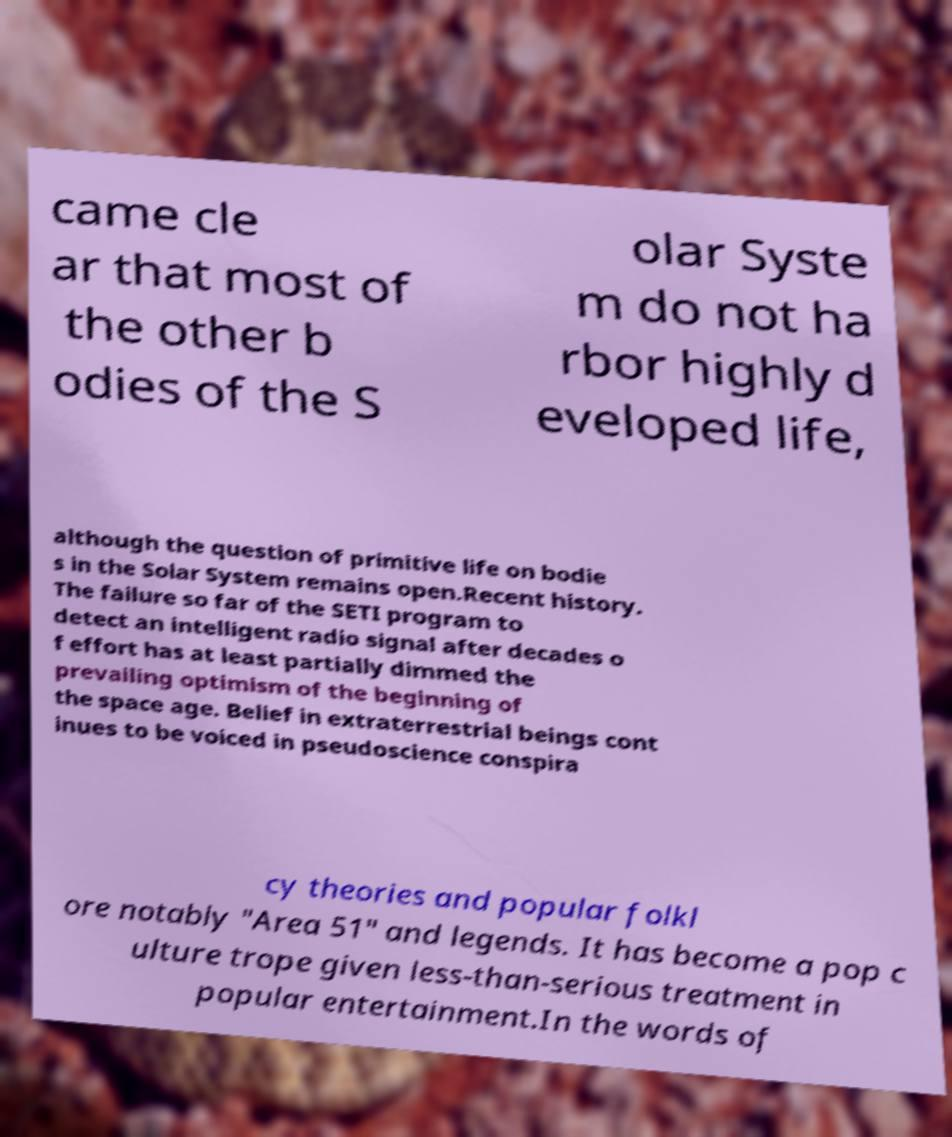Could you assist in decoding the text presented in this image and type it out clearly? came cle ar that most of the other b odies of the S olar Syste m do not ha rbor highly d eveloped life, although the question of primitive life on bodie s in the Solar System remains open.Recent history. The failure so far of the SETI program to detect an intelligent radio signal after decades o f effort has at least partially dimmed the prevailing optimism of the beginning of the space age. Belief in extraterrestrial beings cont inues to be voiced in pseudoscience conspira cy theories and popular folkl ore notably "Area 51" and legends. It has become a pop c ulture trope given less-than-serious treatment in popular entertainment.In the words of 